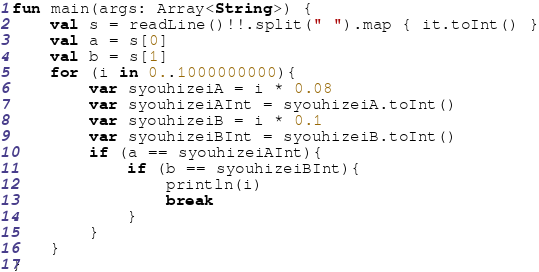<code> <loc_0><loc_0><loc_500><loc_500><_Kotlin_>fun main(args: Array<String>) {
    val s = readLine()!!.split(" ").map { it.toInt() }
    val a = s[0]
    val b = s[1]
    for (i in 0..1000000000){
        var syouhizeiA = i * 0.08
        var syouhizeiAInt = syouhizeiA.toInt()
        var syouhizeiB = i * 0.1
        var syouhizeiBInt = syouhizeiB.toInt()
        if (a == syouhizeiAInt){
            if (b == syouhizeiBInt){
                println(i)
                break
            }
        }
    }
}
</code> 